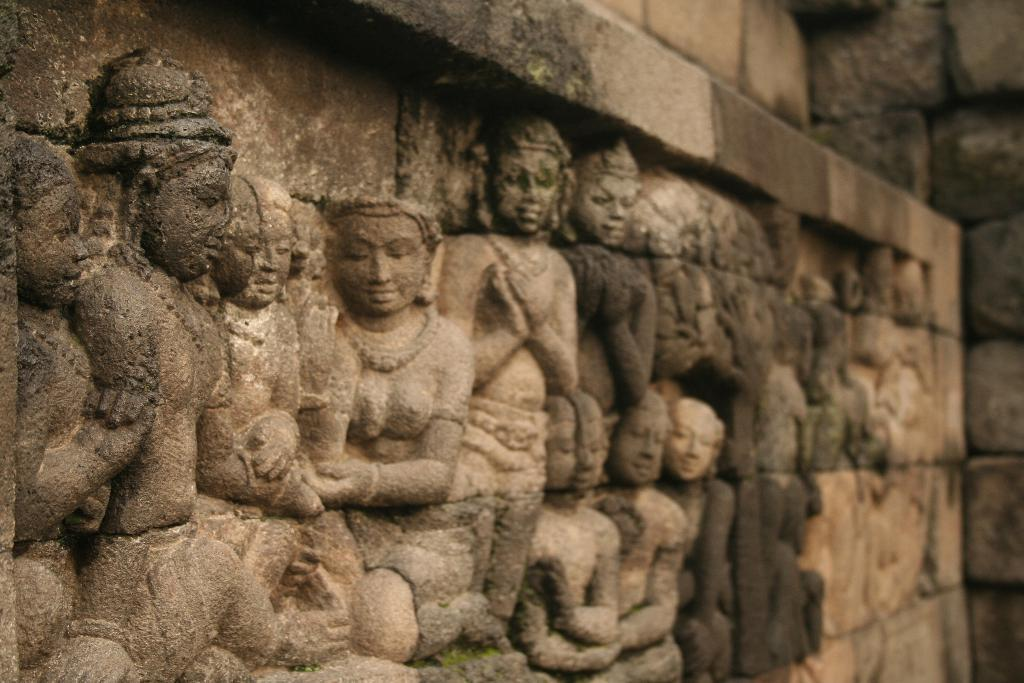What can be seen on the left side of the image? There are architectures and carvings on the left side of the image. What is located at the top of the image? There is a wall at the top of the image. Is there a gun being fired in the image? There is no gun or any indication of gunfire present in the image. What type of cushion can be seen supporting the architectures on the left side of the image? There is no cushion present in the image; the architectures and carvings are supported by the wall at the top of the image. 